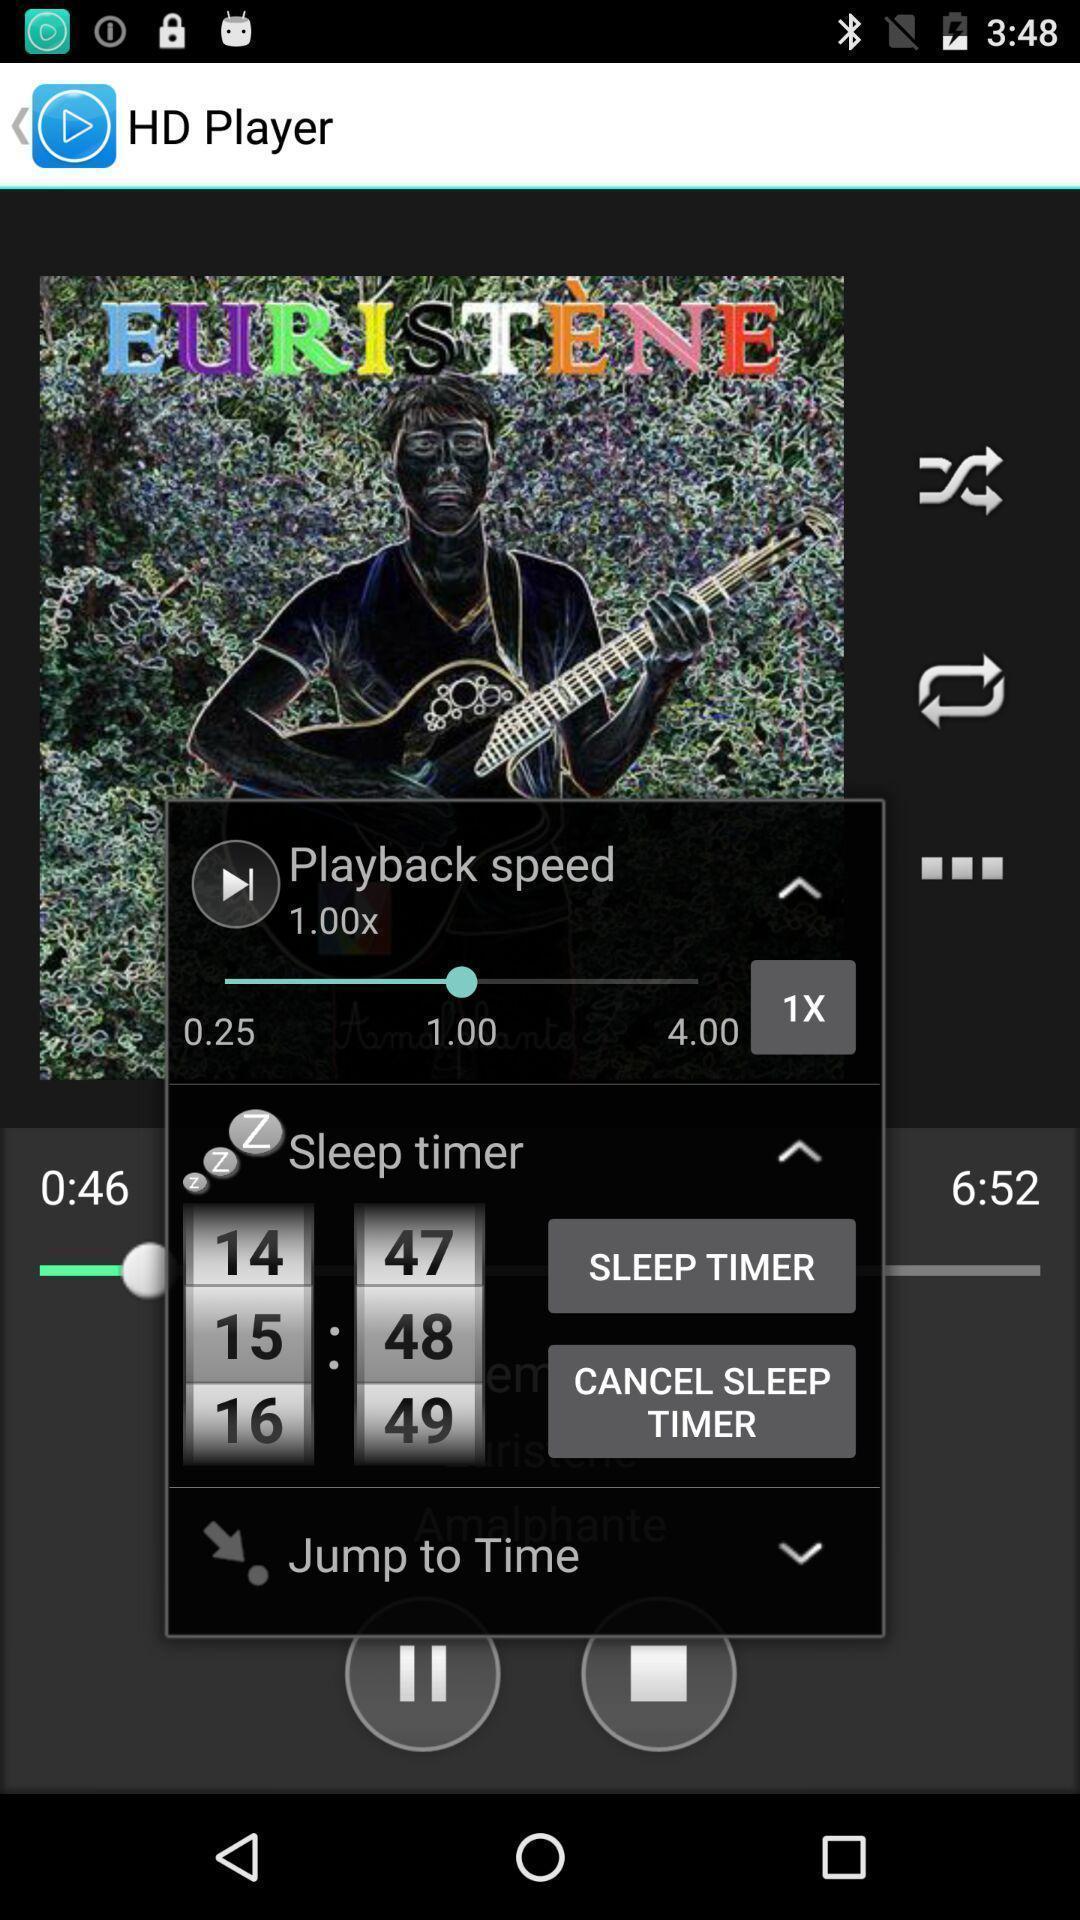Tell me about the visual elements in this screen capture. Push up message with various settings options. 